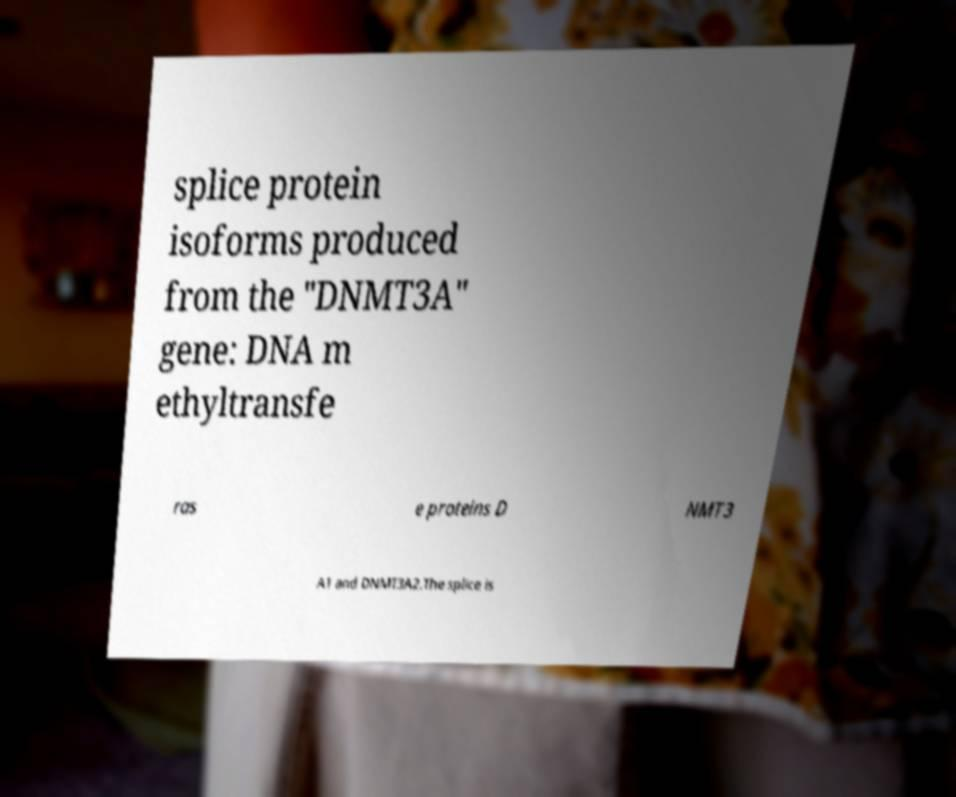Please identify and transcribe the text found in this image. splice protein isoforms produced from the "DNMT3A" gene: DNA m ethyltransfe ras e proteins D NMT3 A1 and DNMT3A2.The splice is 